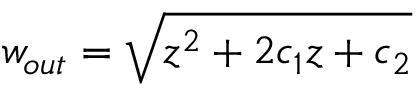<formula> <loc_0><loc_0><loc_500><loc_500>w _ { o u t } = \sqrt { z ^ { 2 } + 2 c _ { 1 } z + c _ { 2 } }</formula> 